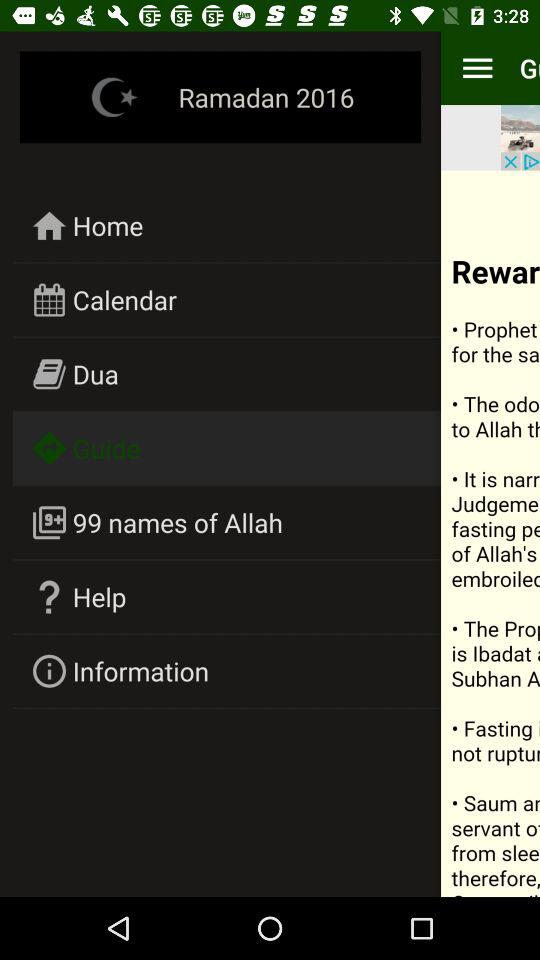How many names of Allah are shown here? There are 99 names of Allah. 